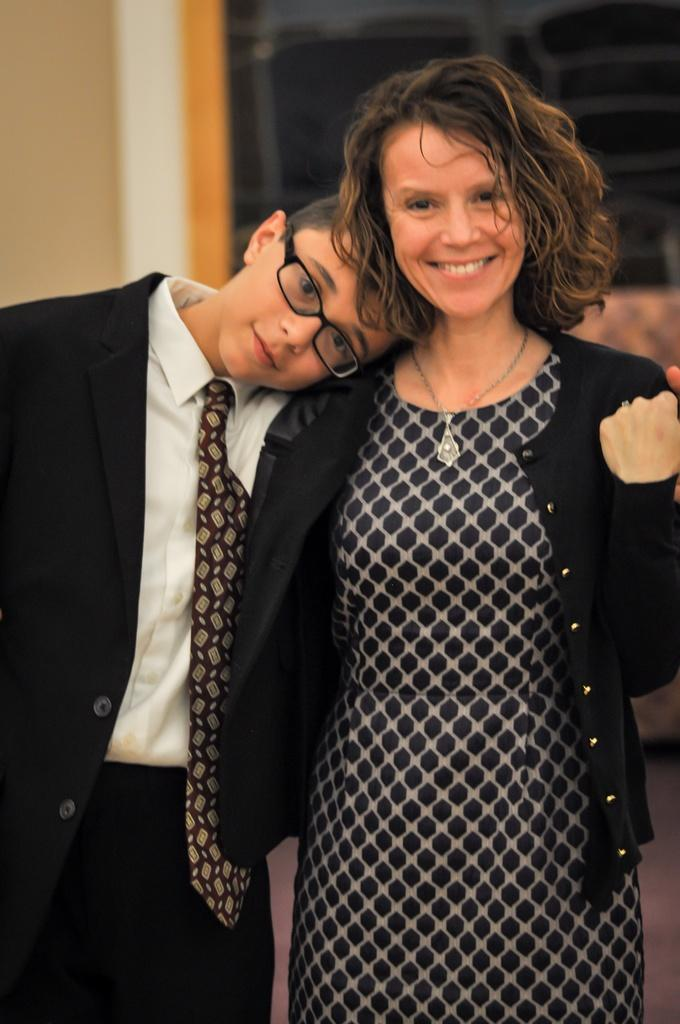How many people are in the image? There are two people in the image. What are the people wearing? Both people are wearing dresses. What colors are the dresses? The dresses are black and white in color. What colors can be seen in the background of the image? The background of the image includes black, white, and brown colors. Is there a patch of grass visible in the image? There is no patch of grass present in the image. Can you see a volcano in the background of the image? There is no volcano visible in the image. 